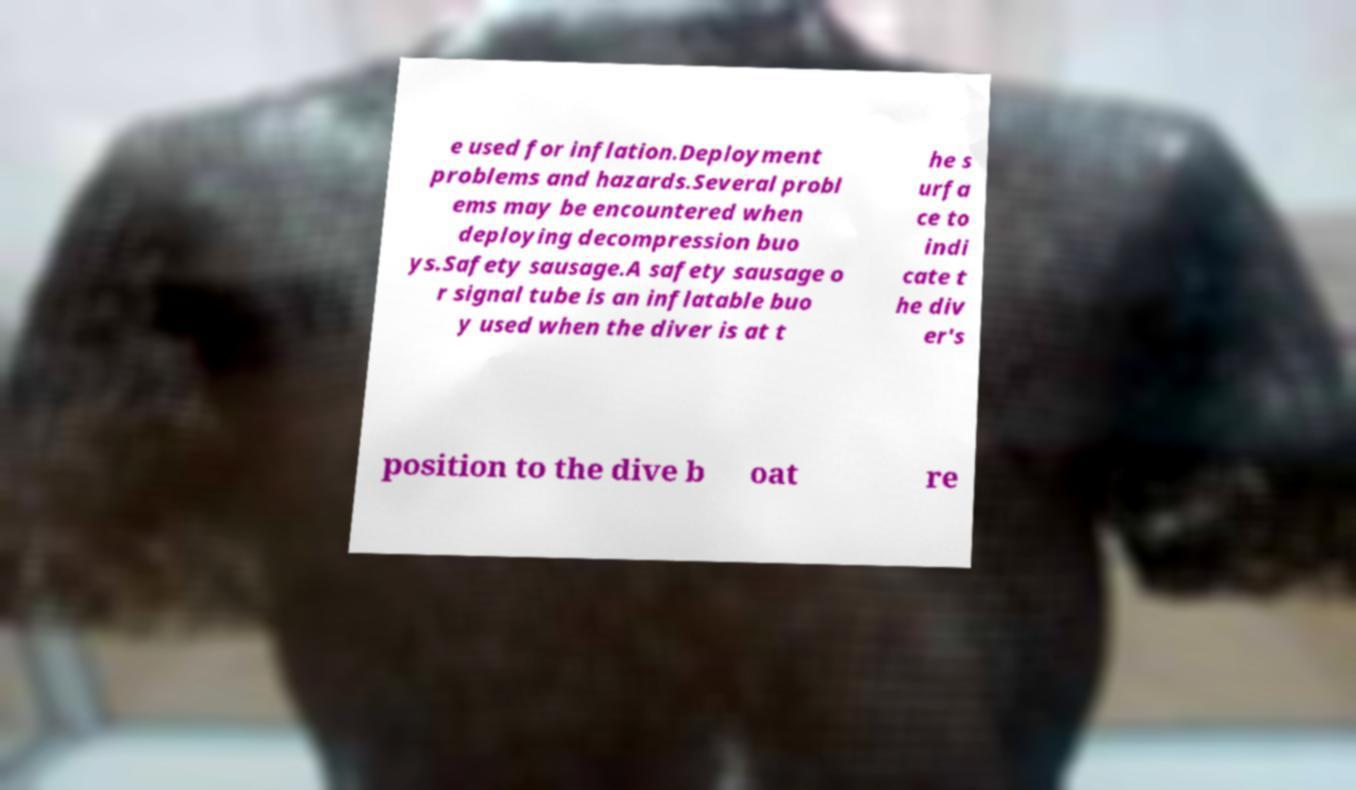I need the written content from this picture converted into text. Can you do that? e used for inflation.Deployment problems and hazards.Several probl ems may be encountered when deploying decompression buo ys.Safety sausage.A safety sausage o r signal tube is an inflatable buo y used when the diver is at t he s urfa ce to indi cate t he div er's position to the dive b oat re 